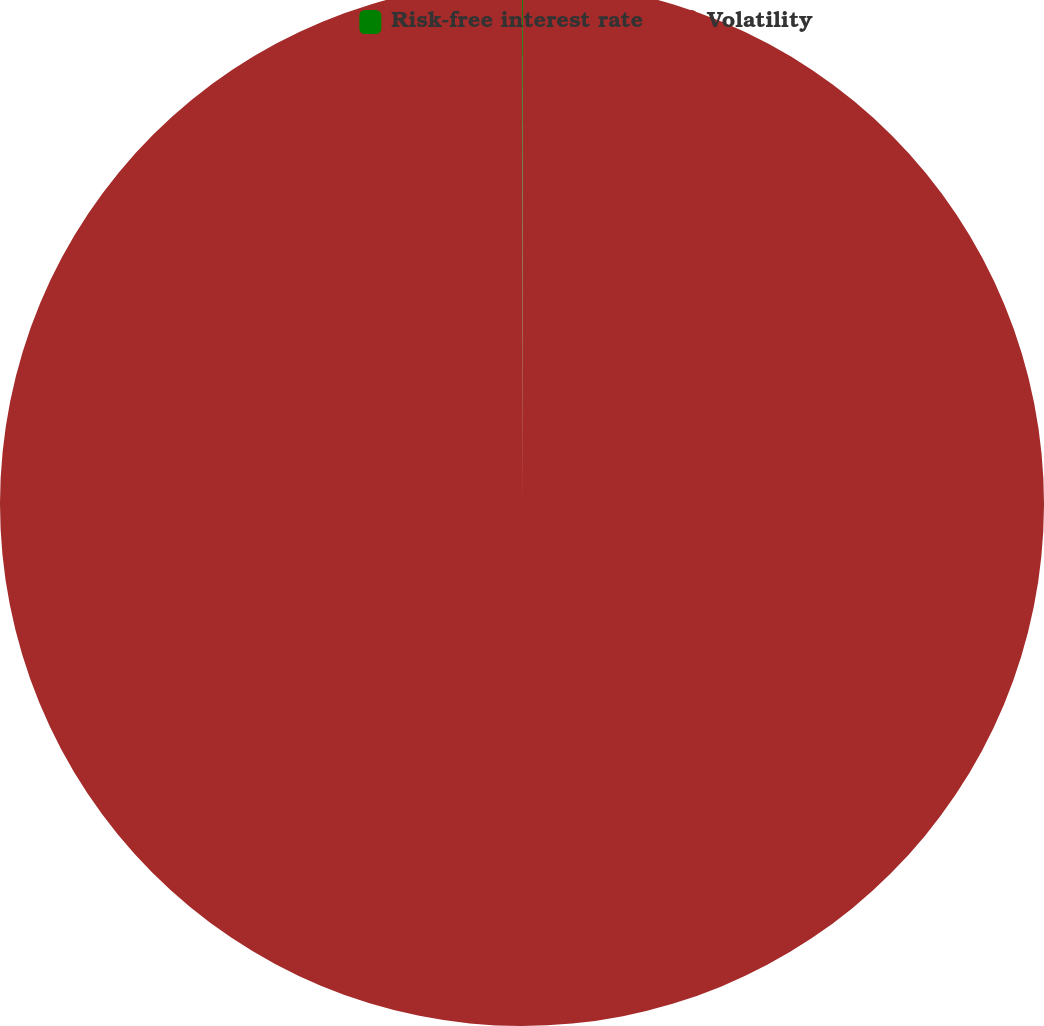Convert chart to OTSL. <chart><loc_0><loc_0><loc_500><loc_500><pie_chart><fcel>Risk-free interest rate<fcel>Volatility<nl><fcel>0.03%<fcel>99.97%<nl></chart> 